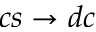<formula> <loc_0><loc_0><loc_500><loc_500>c s \to d c</formula> 